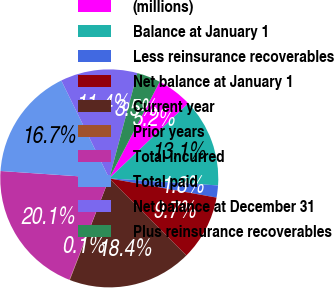Convert chart. <chart><loc_0><loc_0><loc_500><loc_500><pie_chart><fcel>(millions)<fcel>Balance at January 1<fcel>Less reinsurance recoverables<fcel>Net balance at January 1<fcel>Current year<fcel>Prior years<fcel>Total incurred<fcel>Total paid<fcel>Net balance at December 31<fcel>Plus reinsurance recoverables<nl><fcel>5.24%<fcel>13.13%<fcel>1.79%<fcel>9.68%<fcel>18.4%<fcel>0.06%<fcel>20.12%<fcel>16.67%<fcel>11.4%<fcel>3.51%<nl></chart> 